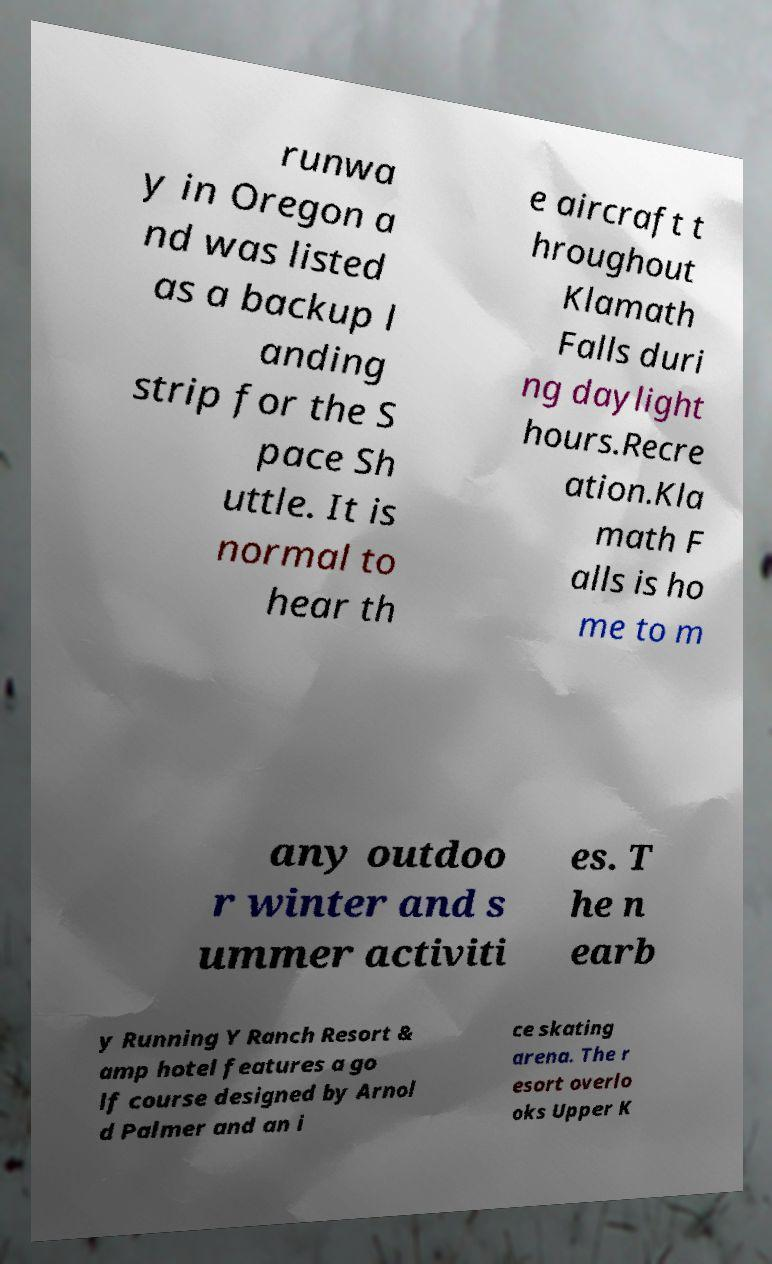What messages or text are displayed in this image? I need them in a readable, typed format. runwa y in Oregon a nd was listed as a backup l anding strip for the S pace Sh uttle. It is normal to hear th e aircraft t hroughout Klamath Falls duri ng daylight hours.Recre ation.Kla math F alls is ho me to m any outdoo r winter and s ummer activiti es. T he n earb y Running Y Ranch Resort & amp hotel features a go lf course designed by Arnol d Palmer and an i ce skating arena. The r esort overlo oks Upper K 